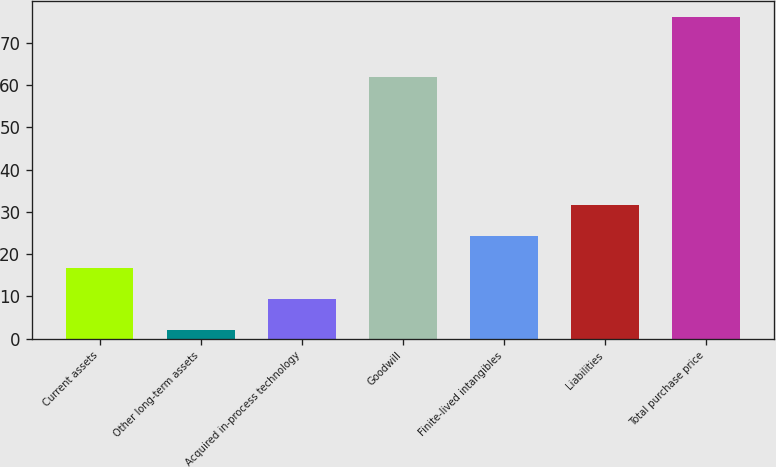Convert chart to OTSL. <chart><loc_0><loc_0><loc_500><loc_500><bar_chart><fcel>Current assets<fcel>Other long-term assets<fcel>Acquired in-process technology<fcel>Goodwill<fcel>Finite-lived intangibles<fcel>Liabilities<fcel>Total purchase price<nl><fcel>16.8<fcel>2<fcel>9.4<fcel>62<fcel>24.2<fcel>31.6<fcel>76<nl></chart> 